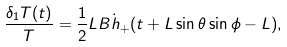<formula> <loc_0><loc_0><loc_500><loc_500>\frac { \delta _ { 1 } T ( t ) } { T } = \frac { 1 } { 2 } L B \dot { h } _ { + } ( t + L \sin \theta \sin \phi - L ) ,</formula> 